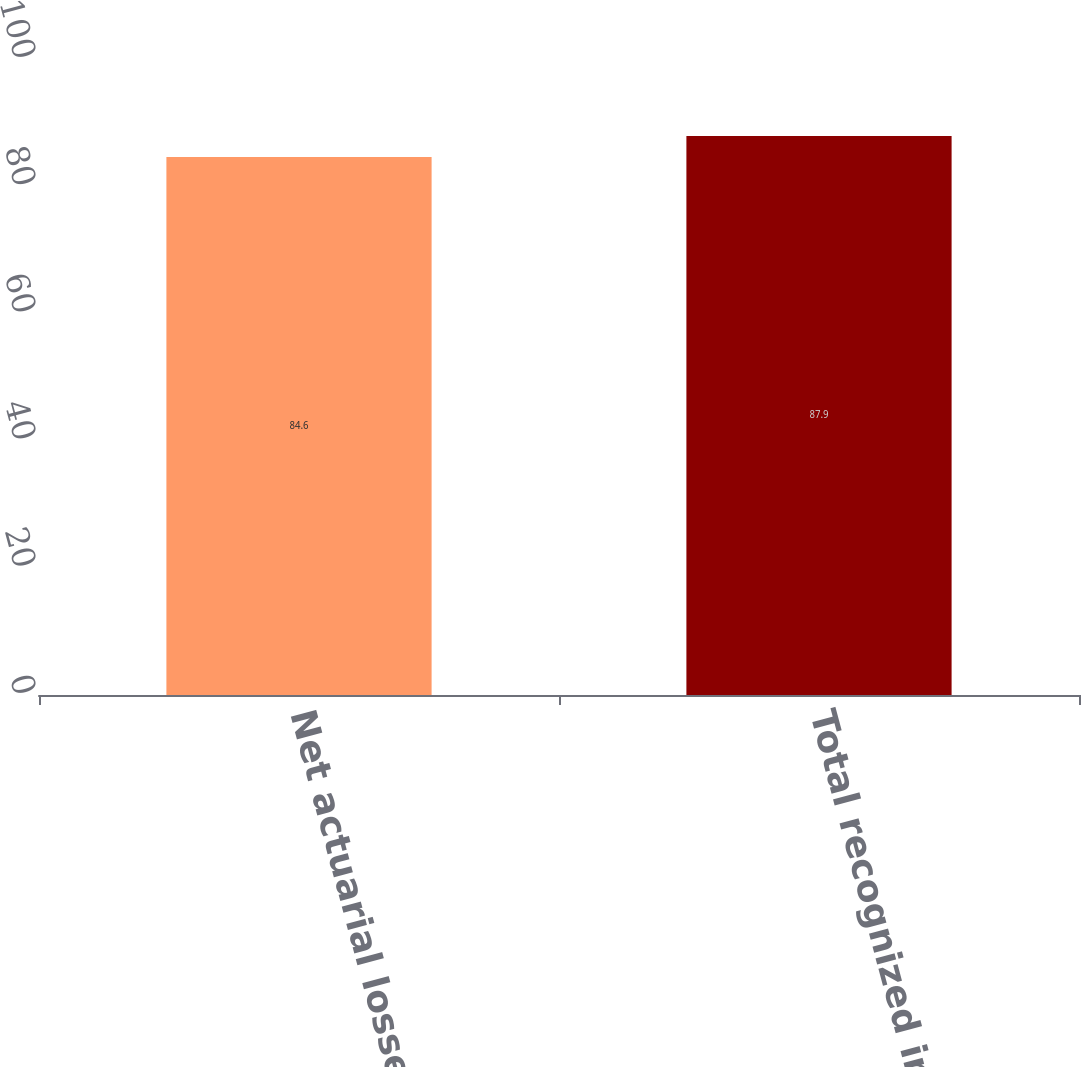Convert chart. <chart><loc_0><loc_0><loc_500><loc_500><bar_chart><fcel>Net actuarial losses<fcel>Total recognized in AOCI-<nl><fcel>84.6<fcel>87.9<nl></chart> 